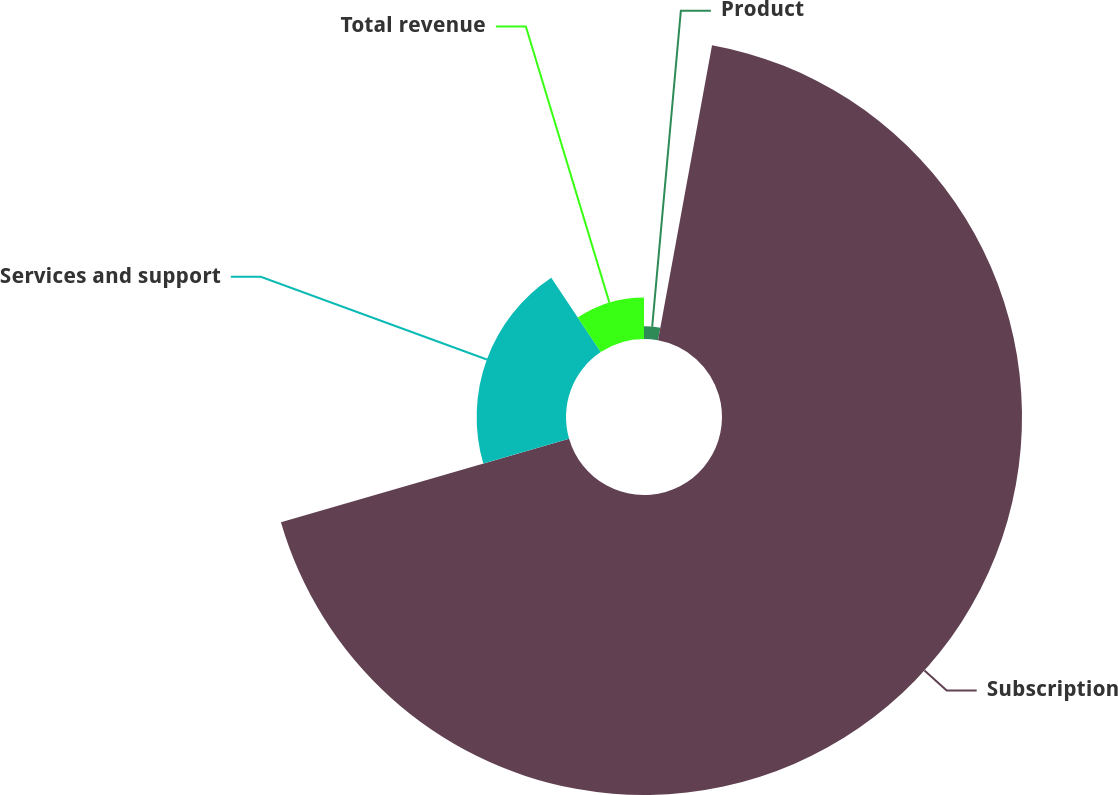Convert chart to OTSL. <chart><loc_0><loc_0><loc_500><loc_500><pie_chart><fcel>Product<fcel>Subscription<fcel>Services and support<fcel>Total revenue<nl><fcel>2.88%<fcel>67.63%<fcel>20.14%<fcel>9.35%<nl></chart> 